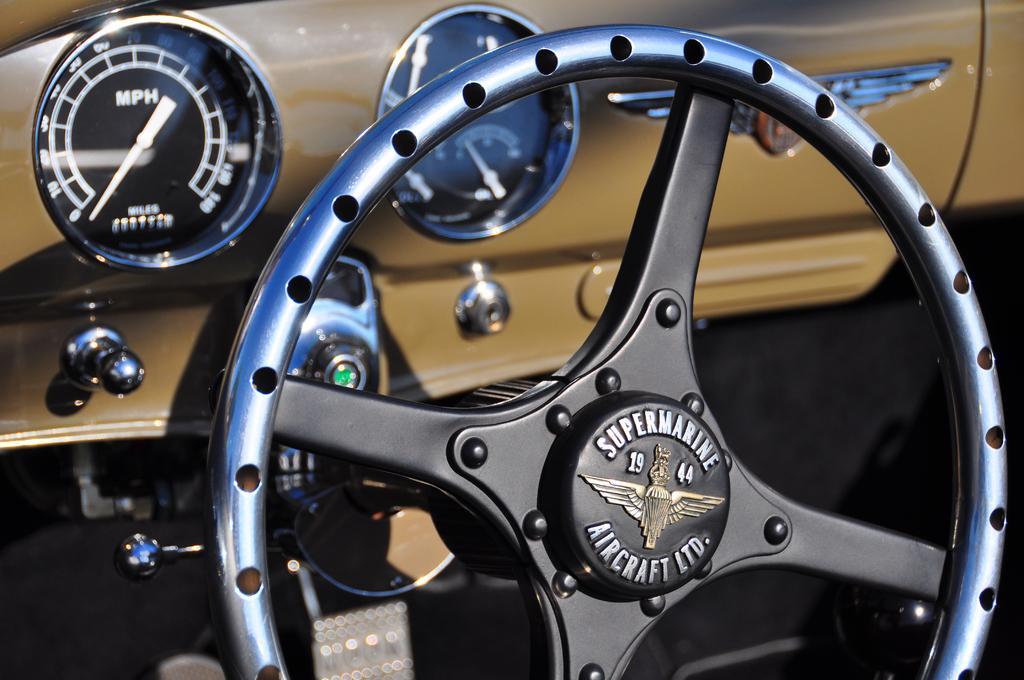What is the main subject of the picture? The main subject of the picture is a vehicle. What specific features can be seen on the vehicle? The vehicle has speed meters and a steering wheel. What type of feast is being prepared in the vehicle? There is no indication of a feast or any food preparation in the image; it only features a vehicle with speed meters and a steering wheel. Who is teaching the driver in the vehicle? There is no indication of a teacher or any teaching activity in the image; it only features a vehicle with speed meters and a steering wheel. 